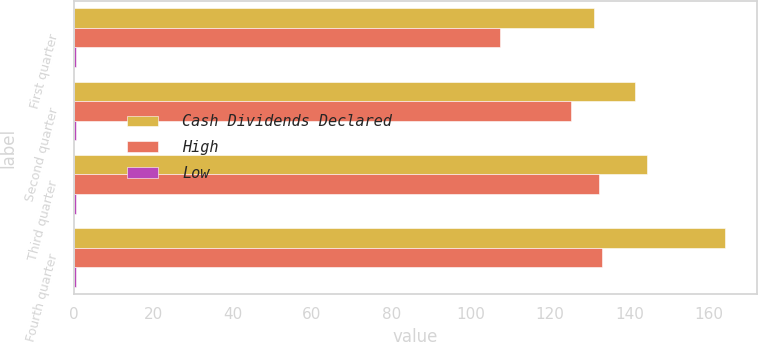Convert chart to OTSL. <chart><loc_0><loc_0><loc_500><loc_500><stacked_bar_chart><ecel><fcel>First quarter<fcel>Second quarter<fcel>Third quarter<fcel>Fourth quarter<nl><fcel>Cash Dividends Declared<fcel>131.1<fcel>141.31<fcel>144.48<fcel>164<nl><fcel>High<fcel>107.51<fcel>125.26<fcel>132.39<fcel>133.03<nl><fcel>Low<fcel>0.5<fcel>0.62<fcel>0.62<fcel>0.62<nl></chart> 